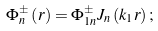Convert formula to latex. <formula><loc_0><loc_0><loc_500><loc_500>\Phi _ { n } ^ { \pm } \left ( r \right ) = \Phi _ { 1 n } ^ { \pm } J _ { n } \left ( k _ { 1 } r \right ) ;</formula> 